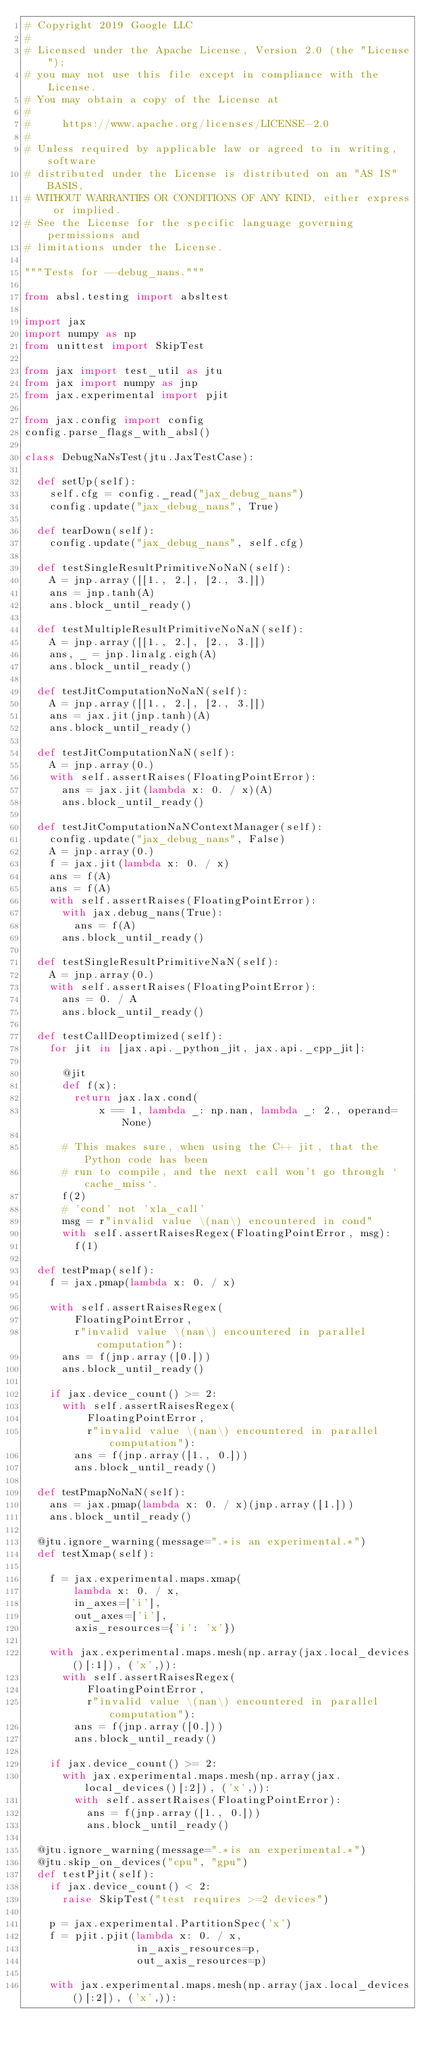<code> <loc_0><loc_0><loc_500><loc_500><_Python_># Copyright 2019 Google LLC
#
# Licensed under the Apache License, Version 2.0 (the "License");
# you may not use this file except in compliance with the License.
# You may obtain a copy of the License at
#
#     https://www.apache.org/licenses/LICENSE-2.0
#
# Unless required by applicable law or agreed to in writing, software
# distributed under the License is distributed on an "AS IS" BASIS,
# WITHOUT WARRANTIES OR CONDITIONS OF ANY KIND, either express or implied.
# See the License for the specific language governing permissions and
# limitations under the License.

"""Tests for --debug_nans."""

from absl.testing import absltest

import jax
import numpy as np
from unittest import SkipTest

from jax import test_util as jtu
from jax import numpy as jnp
from jax.experimental import pjit

from jax.config import config
config.parse_flags_with_absl()

class DebugNaNsTest(jtu.JaxTestCase):

  def setUp(self):
    self.cfg = config._read("jax_debug_nans")
    config.update("jax_debug_nans", True)

  def tearDown(self):
    config.update("jax_debug_nans", self.cfg)

  def testSingleResultPrimitiveNoNaN(self):
    A = jnp.array([[1., 2.], [2., 3.]])
    ans = jnp.tanh(A)
    ans.block_until_ready()

  def testMultipleResultPrimitiveNoNaN(self):
    A = jnp.array([[1., 2.], [2., 3.]])
    ans, _ = jnp.linalg.eigh(A)
    ans.block_until_ready()

  def testJitComputationNoNaN(self):
    A = jnp.array([[1., 2.], [2., 3.]])
    ans = jax.jit(jnp.tanh)(A)
    ans.block_until_ready()

  def testJitComputationNaN(self):
    A = jnp.array(0.)
    with self.assertRaises(FloatingPointError):
      ans = jax.jit(lambda x: 0. / x)(A)
      ans.block_until_ready()

  def testJitComputationNaNContextManager(self):
    config.update("jax_debug_nans", False)
    A = jnp.array(0.)
    f = jax.jit(lambda x: 0. / x)
    ans = f(A)
    ans = f(A)
    with self.assertRaises(FloatingPointError):
      with jax.debug_nans(True):
        ans = f(A)
      ans.block_until_ready()

  def testSingleResultPrimitiveNaN(self):
    A = jnp.array(0.)
    with self.assertRaises(FloatingPointError):
      ans = 0. / A
      ans.block_until_ready()

  def testCallDeoptimized(self):
    for jit in [jax.api._python_jit, jax.api._cpp_jit]:

      @jit
      def f(x):
        return jax.lax.cond(
            x == 1, lambda _: np.nan, lambda _: 2., operand=None)

      # This makes sure, when using the C++ jit, that the Python code has been
      # run to compile, and the next call won't go through `cache_miss`.
      f(2)
      # 'cond' not 'xla_call'
      msg = r"invalid value \(nan\) encountered in cond"
      with self.assertRaisesRegex(FloatingPointError, msg):
        f(1)

  def testPmap(self):
    f = jax.pmap(lambda x: 0. / x)

    with self.assertRaisesRegex(
        FloatingPointError,
        r"invalid value \(nan\) encountered in parallel computation"):
      ans = f(jnp.array([0.]))
      ans.block_until_ready()

    if jax.device_count() >= 2:
      with self.assertRaisesRegex(
          FloatingPointError,
          r"invalid value \(nan\) encountered in parallel computation"):
        ans = f(jnp.array([1., 0.]))
        ans.block_until_ready()

  def testPmapNoNaN(self):
    ans = jax.pmap(lambda x: 0. / x)(jnp.array([1.]))
    ans.block_until_ready()

  @jtu.ignore_warning(message=".*is an experimental.*")
  def testXmap(self):

    f = jax.experimental.maps.xmap(
        lambda x: 0. / x,
        in_axes=['i'],
        out_axes=['i'],
        axis_resources={'i': 'x'})

    with jax.experimental.maps.mesh(np.array(jax.local_devices()[:1]), ('x',)):
      with self.assertRaisesRegex(
          FloatingPointError,
          r"invalid value \(nan\) encountered in parallel computation"):
        ans = f(jnp.array([0.]))
        ans.block_until_ready()

    if jax.device_count() >= 2:
      with jax.experimental.maps.mesh(np.array(jax.local_devices()[:2]), ('x',)):
        with self.assertRaises(FloatingPointError):
          ans = f(jnp.array([1., 0.]))
          ans.block_until_ready()

  @jtu.ignore_warning(message=".*is an experimental.*")
  @jtu.skip_on_devices("cpu", "gpu")
  def testPjit(self):
    if jax.device_count() < 2:
      raise SkipTest("test requires >=2 devices")

    p = jax.experimental.PartitionSpec('x')
    f = pjit.pjit(lambda x: 0. / x,
                  in_axis_resources=p,
                  out_axis_resources=p)

    with jax.experimental.maps.mesh(np.array(jax.local_devices()[:2]), ('x',)):</code> 